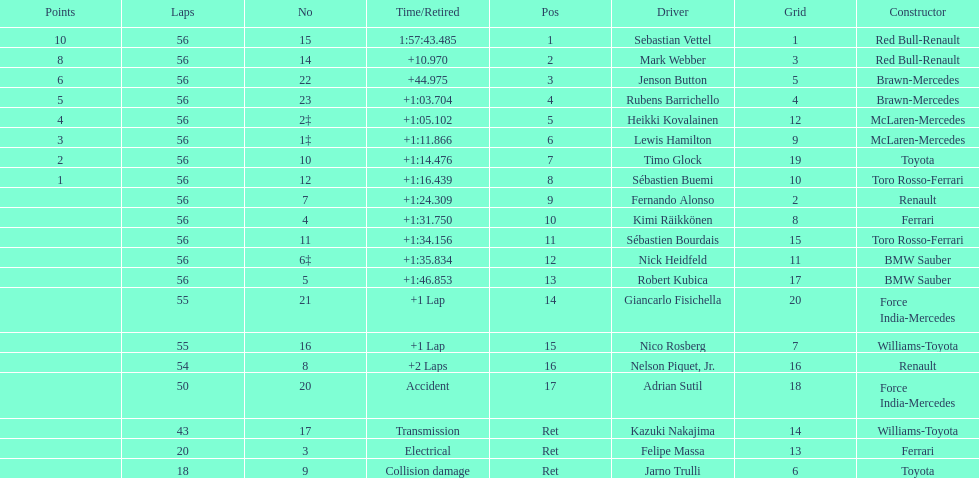How many drivers did not finish 56 laps? 7. 